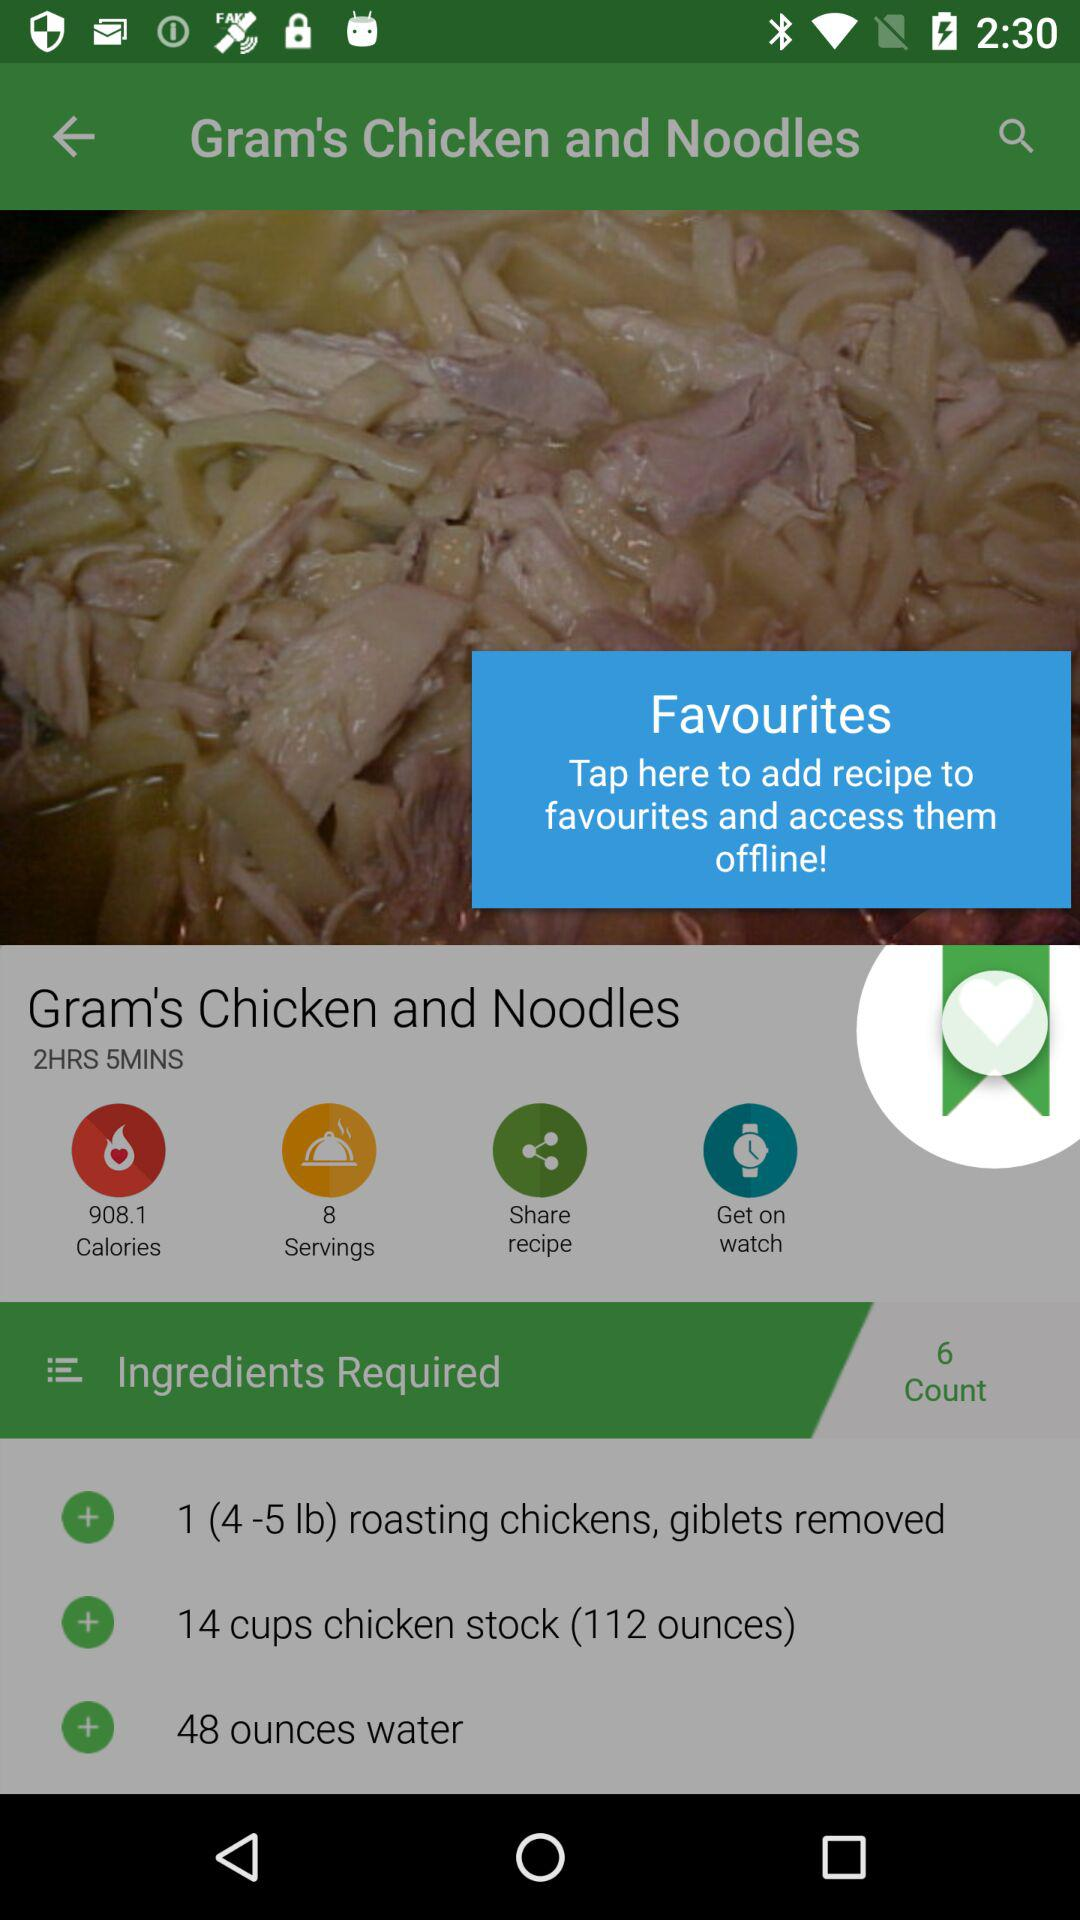Which type of noodle is required for the dish?
When the provided information is insufficient, respond with <no answer>. <no answer> 